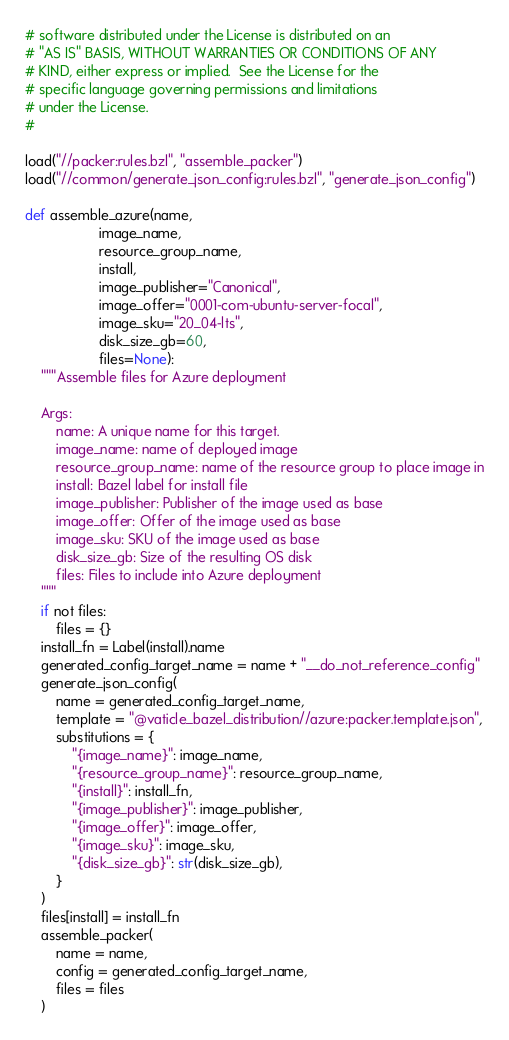Convert code to text. <code><loc_0><loc_0><loc_500><loc_500><_Python_># software distributed under the License is distributed on an
# "AS IS" BASIS, WITHOUT WARRANTIES OR CONDITIONS OF ANY
# KIND, either express or implied.  See the License for the
# specific language governing permissions and limitations
# under the License.
#

load("//packer:rules.bzl", "assemble_packer")
load("//common/generate_json_config:rules.bzl", "generate_json_config")

def assemble_azure(name,
                   image_name,
                   resource_group_name,
                   install,
                   image_publisher="Canonical",
                   image_offer="0001-com-ubuntu-server-focal",
                   image_sku="20_04-lts",
                   disk_size_gb=60,
                   files=None):
    """Assemble files for Azure deployment

    Args:
        name: A unique name for this target.
        image_name: name of deployed image
        resource_group_name: name of the resource group to place image in
        install: Bazel label for install file
        image_publisher: Publisher of the image used as base
        image_offer: Offer of the image used as base
        image_sku: SKU of the image used as base
        disk_size_gb: Size of the resulting OS disk
        files: Files to include into Azure deployment
    """
    if not files:
        files = {}
    install_fn = Label(install).name
    generated_config_target_name = name + "__do_not_reference_config"
    generate_json_config(
        name = generated_config_target_name,
        template = "@vaticle_bazel_distribution//azure:packer.template.json",
        substitutions = {
            "{image_name}": image_name,
            "{resource_group_name}": resource_group_name,
            "{install}": install_fn,
            "{image_publisher}": image_publisher,
            "{image_offer}": image_offer,
            "{image_sku}": image_sku,
            "{disk_size_gb}": str(disk_size_gb),
        }
    )
    files[install] = install_fn
    assemble_packer(
        name = name,
        config = generated_config_target_name,
        files = files
    )
</code> 